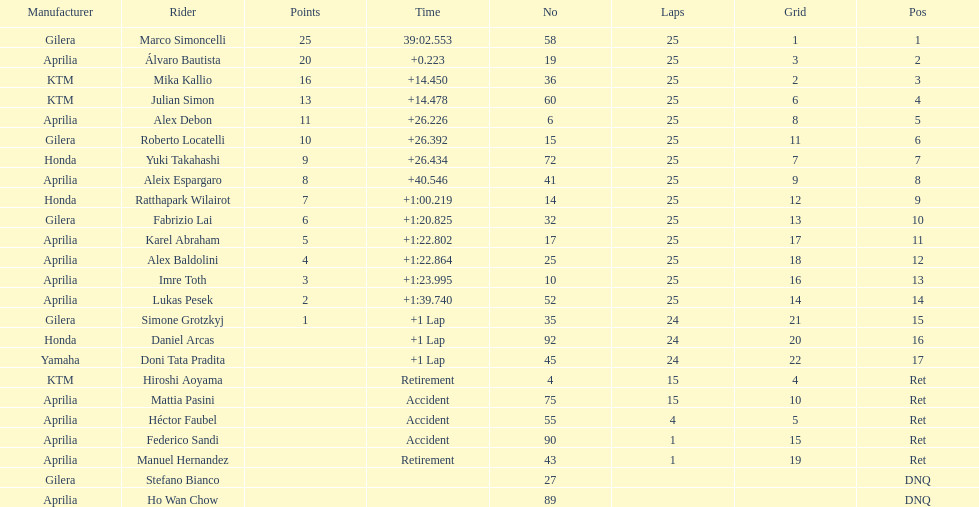Who is marco simoncelli's manufacturer Gilera. 